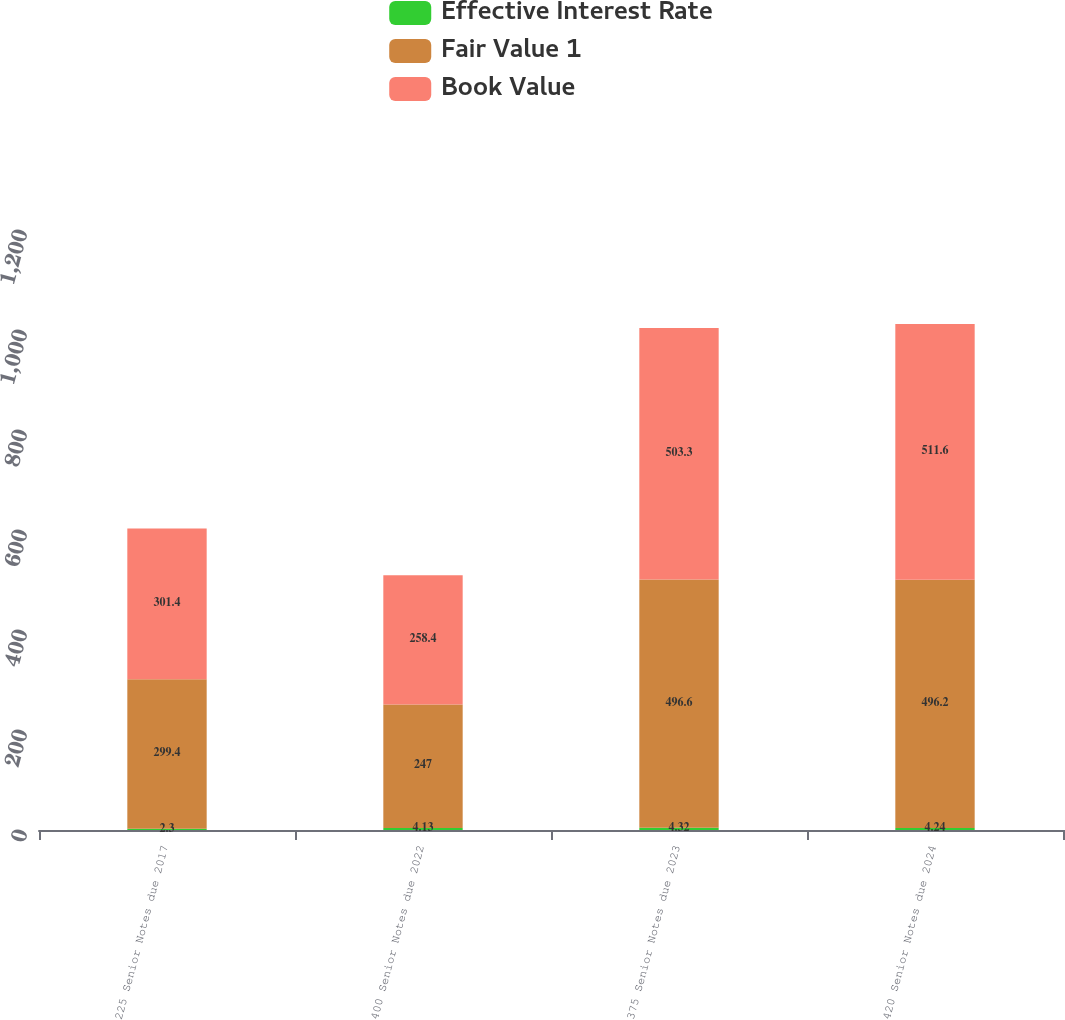Convert chart. <chart><loc_0><loc_0><loc_500><loc_500><stacked_bar_chart><ecel><fcel>225 Senior Notes due 2017<fcel>400 Senior Notes due 2022<fcel>375 Senior Notes due 2023<fcel>420 Senior Notes due 2024<nl><fcel>Effective Interest Rate<fcel>2.3<fcel>4.13<fcel>4.32<fcel>4.24<nl><fcel>Fair Value 1<fcel>299.4<fcel>247<fcel>496.6<fcel>496.2<nl><fcel>Book Value<fcel>301.4<fcel>258.4<fcel>503.3<fcel>511.6<nl></chart> 